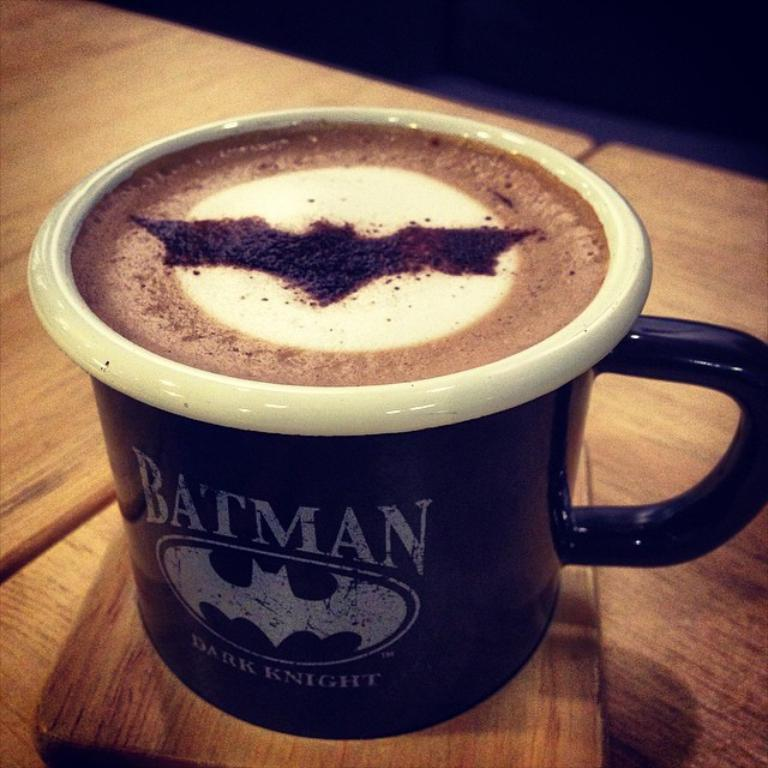What type of coffee cup is visible in the image? There is a black coffee cup in the image. Where is the coffee cup located? The coffee cup is on a wooden surface. What type of business is being conducted in the image? There is no indication of any business being conducted in the image; it only shows a black coffee cup on a wooden surface. 